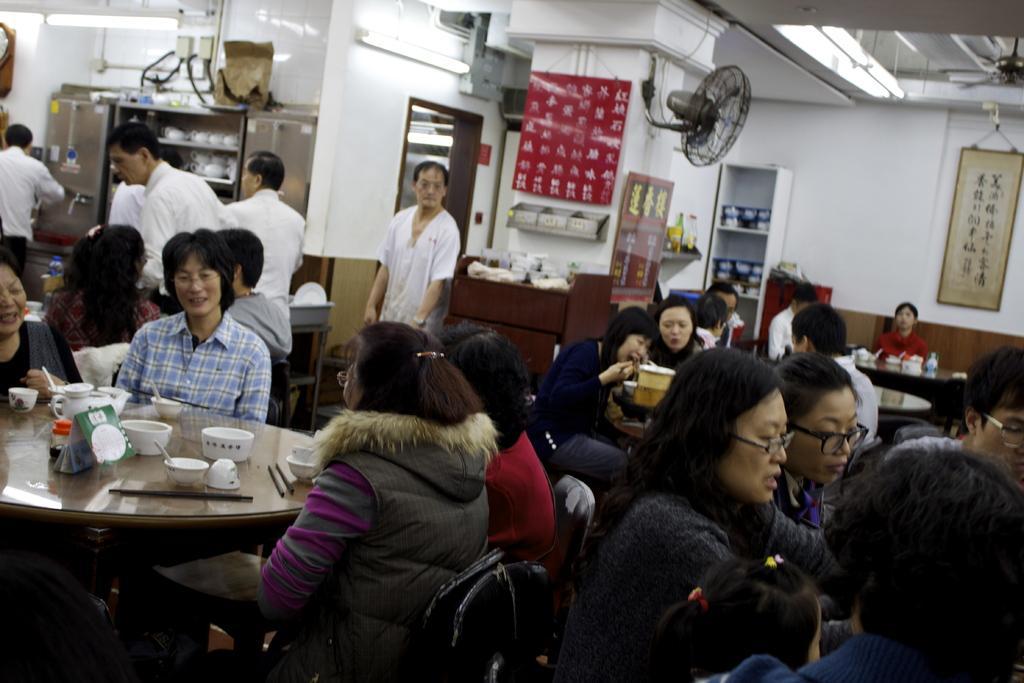In one or two sentences, can you explain what this image depicts? In this image we can see many people are sitting around the table. In the background we can see a fan, banner and wall hanging. 